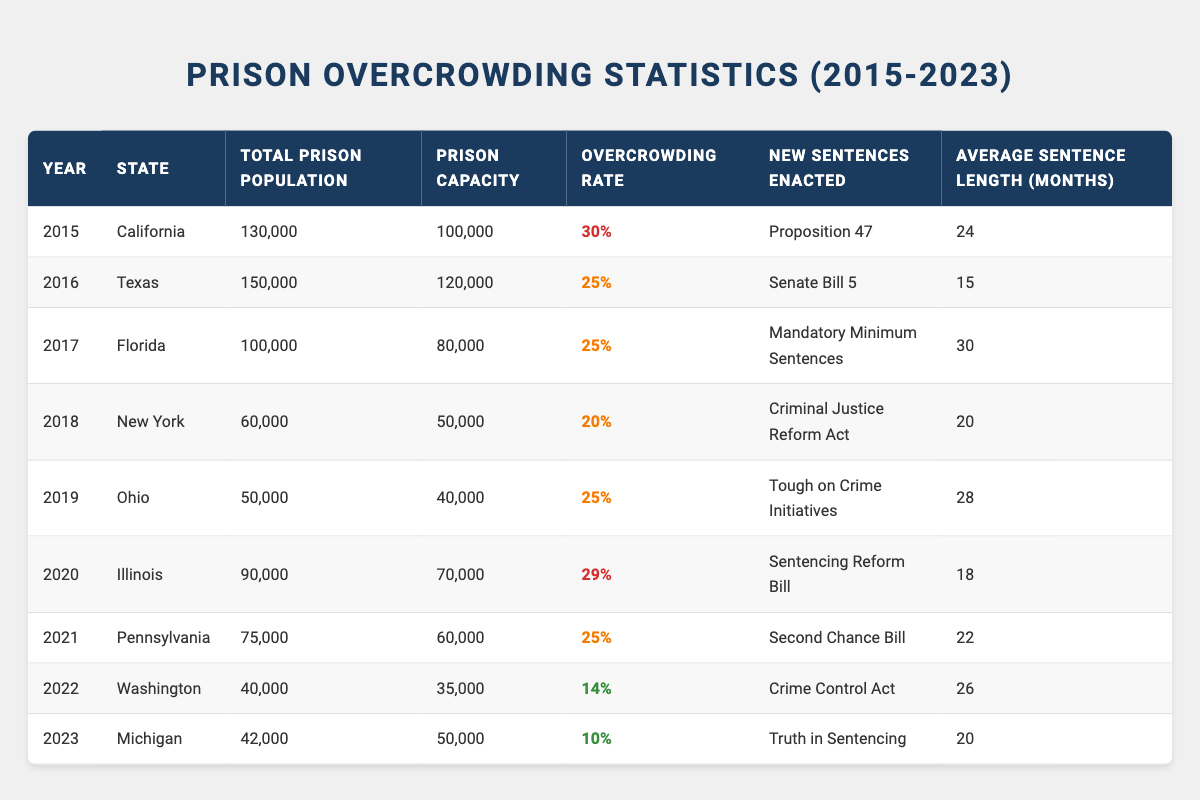What was the overcrowding rate in California in 2015? The table lists California's overcrowding rate for the year 2015 as 30%.
Answer: 30% How many states had a total prison population exceeding 100,000 in 2016? The table shows that Texas with 150,000 and Florida with 100,000 both are detailed. Hence, there is one state exceeding 100,000.
Answer: 1 What was the average sentence length in months for New York in 2018? The table indicates that the average sentence length for New York in 2018 was 20 months.
Answer: 20 In which year did the overcrowding rate drop to 10%? The table shows that the overcrowding rate dropped to 10% in Michigan in 2023.
Answer: 2023 What is the average overcrowding rate from 2015 to 2023? To find the average, add the overcrowding rates (30 + 25 + 25 + 20 + 25 + 29 + 25 + 14 + 10) =  209, then divide by the number of years (9). The average is 209/9 = approximately 23.2%.
Answer: 23.2% Was there an increase in the total prison population from 2015 to 2021? Comparing the total prison population in 2015 (130,000) and in 2021 (75,000), there's a decrease from 130,000 to 75,000, thus the answer is no.
Answer: No Which state had the lowest overcrowding rate in 2022 based on the table? The table indicates that Washington had the lowest overcrowding rate in 2022 at 14%.
Answer: Washington How did the average sentence length change from Texas in 2016 to Florida in 2017? Texas had an average sentence length of 15 months in 2016 while Florida had 30 months in 2017. This reflects an increase of 15 months from Texas to Florida.
Answer: Increased by 15 months Which state enacted "Truth in Sentencing" and what was its overcrowding rate? According to the table, Michigan enacted "Truth in Sentencing" and the overcrowding rate for this state in 2023 was 10%.
Answer: Michigan, 10% How many states had overcrowding rates of 25% or higher between 2015 and 2021? Checking the table, the states with 25% or higher include California (30%), Texas (25%), Florida (25%), Illinois (29%), and Pennsylvania (25%), totaling 5 states.
Answer: 5 states Was the overall trend for overcrowding rates from 2020 to 2023 decreasing? Based on the table, the overcrowding rates for 2020 (29%), 2021 (25%), 2022 (14%), and 2023 (10%) all show a downward trend, confirming the statement is true.
Answer: Yes 